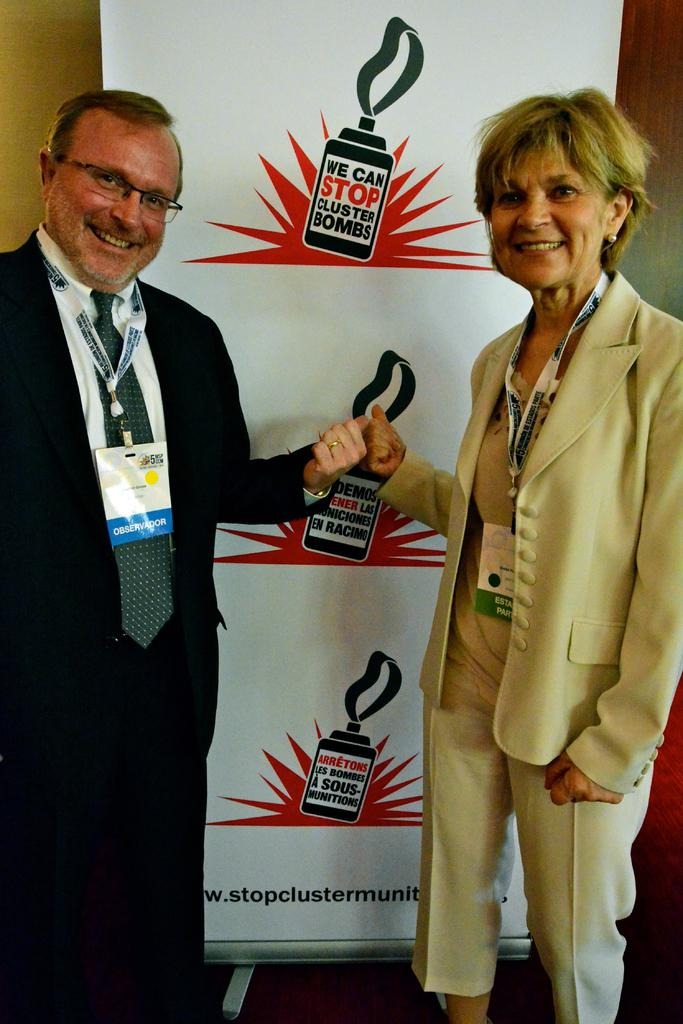How many people are in the image? There are two people in the image, a man and a woman. What are the man and woman doing in the image? The man and woman are standing and smiling. What are they wearing that identifies them? The man and woman are wearing ID cards. What can be seen in the background of the image? There is a banner in the background of the image. What is written on the banner? The banner has something written on it. What type of cushion is the man sitting on in the image? There is no cushion present in the image, and the man is not sitting; he is standing. Who needs to approve the man and woman's actions in the image? There is no indication in the image that their actions require approval from anyone. --- Facts: 1. There is a car in the image. 2. The car is red. 3. The car has four wheels. 4. There is a person in the car. 5. The person is wearing a seatbelt. 6. The car is parked on the side of the road. Absurd Topics: parrot, dance, ocean Conversation: What is the main subject of the image? The main subject of the image is a car. What color is the car? The car is red. How many wheels does the car have? The car has four wheels. Is there anyone inside the car? Yes, there is a person in the car. What safety measure is the person in the car taking? The person is wearing a seatbelt. Where is the car located in the image? The car is parked on the side of the road. Reasoning: Let's think step by step in order to produce the conversation. We start by identifying the main subject in the image, which is the car. Then, we describe the car's color and the number of wheels it has. Next, we mention the presence of a person inside the car and their safety precaution. Finally, we describe the car's location in the image. Each question is designed to elicit a specific detail about the image that is known from the provided facts. Absurd Question/Answer: Can you see a parrot dancing on the ocean in the image? There is no parrot or ocean present in the image; it features a red car parked on the side of the road with a person wearing a seatbelt. 